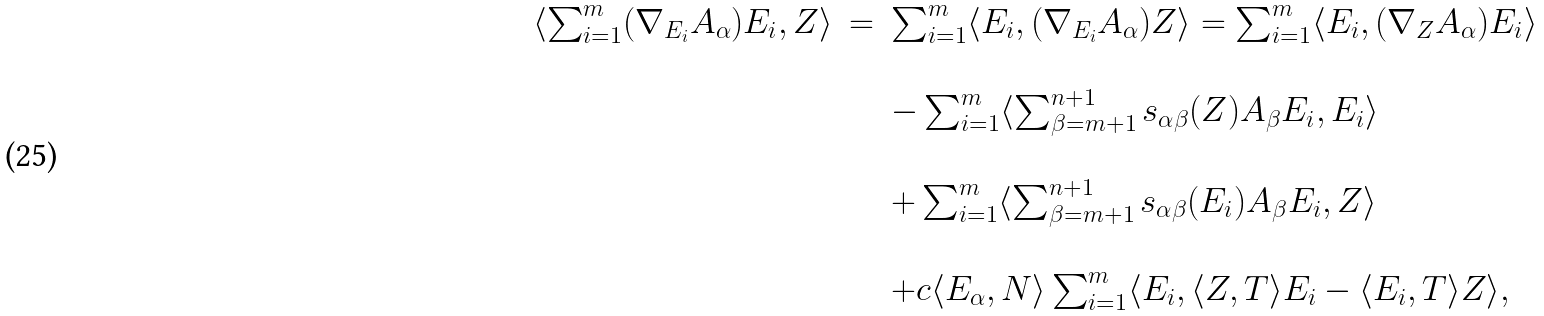Convert formula to latex. <formula><loc_0><loc_0><loc_500><loc_500>\begin{array} { l c l } \langle \sum _ { i = 1 } ^ { m } ( \nabla _ { E _ { i } } A _ { \alpha } ) E _ { i } , Z \rangle & = & \sum _ { i = 1 } ^ { m } \langle E _ { i } , ( \nabla _ { E _ { i } } A _ { \alpha } ) Z \rangle = \sum _ { i = 1 } ^ { m } \langle E _ { i } , ( \nabla _ { Z } A _ { \alpha } ) E _ { i } \rangle \\ \\ & & - \sum _ { i = 1 } ^ { m } \langle \sum _ { \beta = m + 1 } ^ { n + 1 } s _ { \alpha \beta } ( Z ) A _ { \beta } E _ { i } , E _ { i } \rangle \\ \\ & & + \sum _ { i = 1 } ^ { m } \langle \sum _ { \beta = m + 1 } ^ { n + 1 } s _ { \alpha \beta } ( E _ { i } ) A _ { \beta } E _ { i } , Z \rangle \\ \\ & & + c \langle E _ { \alpha } , N \rangle \sum _ { i = 1 } ^ { m } \langle E _ { i } , \langle Z , T \rangle E _ { i } - \langle E _ { i } , T \rangle Z \rangle , \end{array}</formula> 